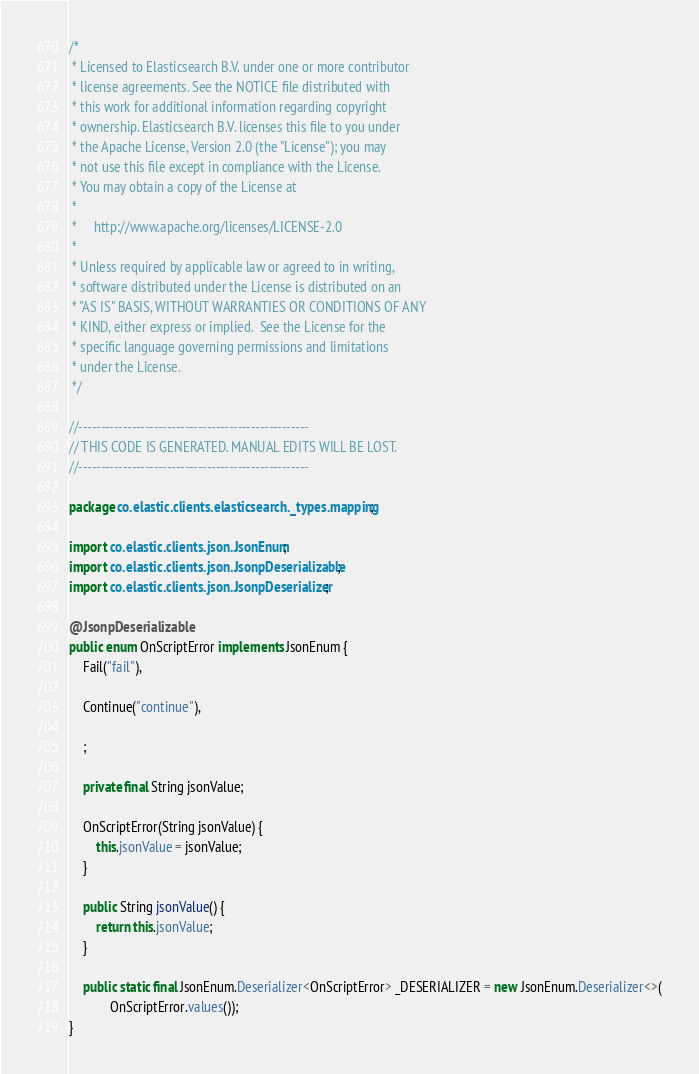Convert code to text. <code><loc_0><loc_0><loc_500><loc_500><_Java_>/*
 * Licensed to Elasticsearch B.V. under one or more contributor
 * license agreements. See the NOTICE file distributed with
 * this work for additional information regarding copyright
 * ownership. Elasticsearch B.V. licenses this file to you under
 * the Apache License, Version 2.0 (the "License"); you may
 * not use this file except in compliance with the License.
 * You may obtain a copy of the License at
 *
 *     http://www.apache.org/licenses/LICENSE-2.0
 *
 * Unless required by applicable law or agreed to in writing,
 * software distributed under the License is distributed on an
 * "AS IS" BASIS, WITHOUT WARRANTIES OR CONDITIONS OF ANY
 * KIND, either express or implied.  See the License for the
 * specific language governing permissions and limitations
 * under the License.
 */

//----------------------------------------------------
// THIS CODE IS GENERATED. MANUAL EDITS WILL BE LOST.
//----------------------------------------------------

package co.elastic.clients.elasticsearch._types.mapping;

import co.elastic.clients.json.JsonEnum;
import co.elastic.clients.json.JsonpDeserializable;
import co.elastic.clients.json.JsonpDeserializer;

@JsonpDeserializable
public enum OnScriptError implements JsonEnum {
	Fail("fail"),

	Continue("continue"),

	;

	private final String jsonValue;

	OnScriptError(String jsonValue) {
		this.jsonValue = jsonValue;
	}

	public String jsonValue() {
		return this.jsonValue;
	}

	public static final JsonEnum.Deserializer<OnScriptError> _DESERIALIZER = new JsonEnum.Deserializer<>(
			OnScriptError.values());
}
</code> 